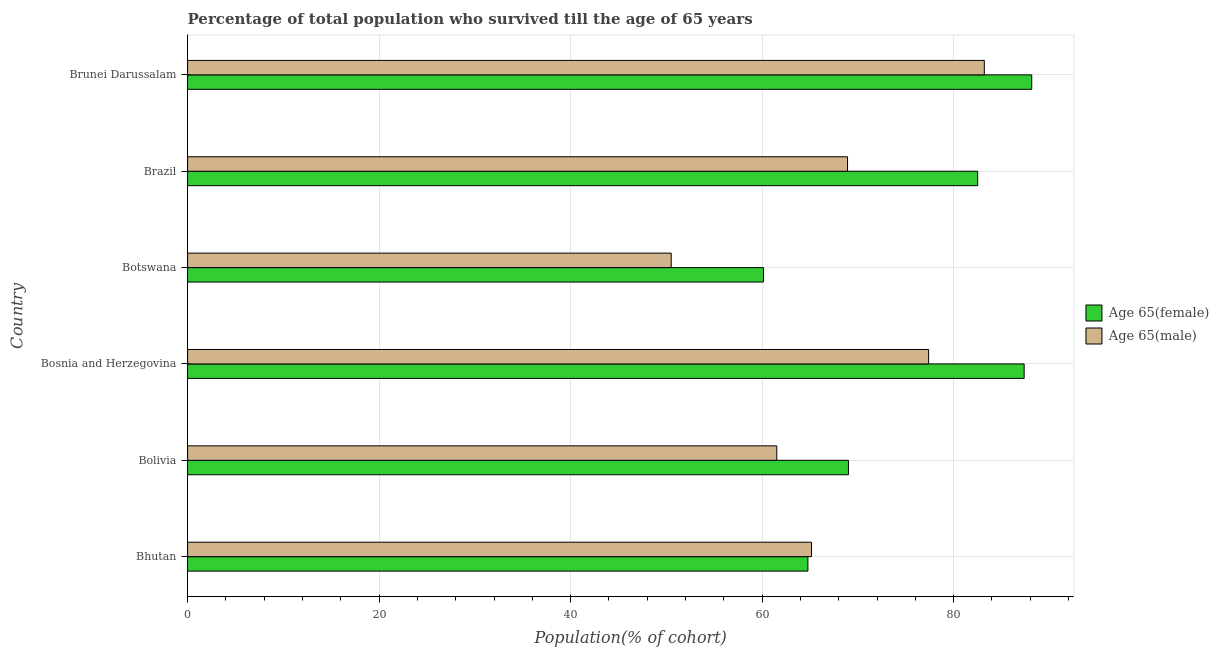How many different coloured bars are there?
Make the answer very short. 2. How many groups of bars are there?
Offer a terse response. 6. How many bars are there on the 5th tick from the bottom?
Make the answer very short. 2. What is the label of the 3rd group of bars from the top?
Make the answer very short. Botswana. In how many cases, is the number of bars for a given country not equal to the number of legend labels?
Ensure brevity in your answer.  0. What is the percentage of male population who survived till age of 65 in Brunei Darussalam?
Your response must be concise. 83.21. Across all countries, what is the maximum percentage of male population who survived till age of 65?
Offer a terse response. 83.21. Across all countries, what is the minimum percentage of female population who survived till age of 65?
Your response must be concise. 60.14. In which country was the percentage of male population who survived till age of 65 maximum?
Your response must be concise. Brunei Darussalam. In which country was the percentage of female population who survived till age of 65 minimum?
Make the answer very short. Botswana. What is the total percentage of male population who survived till age of 65 in the graph?
Make the answer very short. 406.72. What is the difference between the percentage of female population who survived till age of 65 in Botswana and that in Brunei Darussalam?
Your answer should be compact. -28.02. What is the difference between the percentage of female population who survived till age of 65 in Bolivia and the percentage of male population who survived till age of 65 in Brunei Darussalam?
Ensure brevity in your answer.  -14.19. What is the average percentage of male population who survived till age of 65 per country?
Ensure brevity in your answer.  67.79. What is the difference between the percentage of male population who survived till age of 65 and percentage of female population who survived till age of 65 in Bolivia?
Give a very brief answer. -7.49. What is the ratio of the percentage of female population who survived till age of 65 in Bolivia to that in Botswana?
Provide a succinct answer. 1.15. Is the percentage of male population who survived till age of 65 in Bolivia less than that in Brazil?
Make the answer very short. Yes. What is the difference between the highest and the second highest percentage of male population who survived till age of 65?
Offer a very short reply. 5.82. What is the difference between the highest and the lowest percentage of male population who survived till age of 65?
Offer a terse response. 32.7. In how many countries, is the percentage of male population who survived till age of 65 greater than the average percentage of male population who survived till age of 65 taken over all countries?
Your response must be concise. 3. Is the sum of the percentage of female population who survived till age of 65 in Bosnia and Herzegovina and Botswana greater than the maximum percentage of male population who survived till age of 65 across all countries?
Provide a succinct answer. Yes. What does the 2nd bar from the top in Bosnia and Herzegovina represents?
Provide a short and direct response. Age 65(female). What does the 1st bar from the bottom in Bosnia and Herzegovina represents?
Ensure brevity in your answer.  Age 65(female). How many bars are there?
Give a very brief answer. 12. Does the graph contain grids?
Ensure brevity in your answer.  Yes. Where does the legend appear in the graph?
Provide a short and direct response. Center right. What is the title of the graph?
Provide a short and direct response. Percentage of total population who survived till the age of 65 years. What is the label or title of the X-axis?
Provide a succinct answer. Population(% of cohort). What is the label or title of the Y-axis?
Ensure brevity in your answer.  Country. What is the Population(% of cohort) of Age 65(female) in Bhutan?
Your answer should be very brief. 64.78. What is the Population(% of cohort) in Age 65(male) in Bhutan?
Your answer should be compact. 65.16. What is the Population(% of cohort) of Age 65(female) in Bolivia?
Your answer should be very brief. 69.02. What is the Population(% of cohort) of Age 65(male) in Bolivia?
Provide a succinct answer. 61.53. What is the Population(% of cohort) in Age 65(female) in Bosnia and Herzegovina?
Provide a succinct answer. 87.37. What is the Population(% of cohort) in Age 65(male) in Bosnia and Herzegovina?
Offer a terse response. 77.39. What is the Population(% of cohort) in Age 65(female) in Botswana?
Offer a terse response. 60.14. What is the Population(% of cohort) of Age 65(male) in Botswana?
Your answer should be very brief. 50.51. What is the Population(% of cohort) in Age 65(female) in Brazil?
Give a very brief answer. 82.51. What is the Population(% of cohort) in Age 65(male) in Brazil?
Make the answer very short. 68.92. What is the Population(% of cohort) of Age 65(female) in Brunei Darussalam?
Your answer should be compact. 88.16. What is the Population(% of cohort) of Age 65(male) in Brunei Darussalam?
Your answer should be compact. 83.21. Across all countries, what is the maximum Population(% of cohort) of Age 65(female)?
Make the answer very short. 88.16. Across all countries, what is the maximum Population(% of cohort) of Age 65(male)?
Your answer should be very brief. 83.21. Across all countries, what is the minimum Population(% of cohort) of Age 65(female)?
Your answer should be compact. 60.14. Across all countries, what is the minimum Population(% of cohort) of Age 65(male)?
Your response must be concise. 50.51. What is the total Population(% of cohort) of Age 65(female) in the graph?
Offer a terse response. 451.99. What is the total Population(% of cohort) in Age 65(male) in the graph?
Provide a succinct answer. 406.72. What is the difference between the Population(% of cohort) in Age 65(female) in Bhutan and that in Bolivia?
Your answer should be very brief. -4.23. What is the difference between the Population(% of cohort) of Age 65(male) in Bhutan and that in Bolivia?
Give a very brief answer. 3.63. What is the difference between the Population(% of cohort) of Age 65(female) in Bhutan and that in Bosnia and Herzegovina?
Your answer should be very brief. -22.58. What is the difference between the Population(% of cohort) of Age 65(male) in Bhutan and that in Bosnia and Herzegovina?
Your response must be concise. -12.23. What is the difference between the Population(% of cohort) in Age 65(female) in Bhutan and that in Botswana?
Offer a very short reply. 4.64. What is the difference between the Population(% of cohort) in Age 65(male) in Bhutan and that in Botswana?
Give a very brief answer. 14.65. What is the difference between the Population(% of cohort) in Age 65(female) in Bhutan and that in Brazil?
Provide a short and direct response. -17.73. What is the difference between the Population(% of cohort) in Age 65(male) in Bhutan and that in Brazil?
Offer a terse response. -3.76. What is the difference between the Population(% of cohort) of Age 65(female) in Bhutan and that in Brunei Darussalam?
Provide a short and direct response. -23.38. What is the difference between the Population(% of cohort) in Age 65(male) in Bhutan and that in Brunei Darussalam?
Your response must be concise. -18.05. What is the difference between the Population(% of cohort) in Age 65(female) in Bolivia and that in Bosnia and Herzegovina?
Offer a terse response. -18.35. What is the difference between the Population(% of cohort) in Age 65(male) in Bolivia and that in Bosnia and Herzegovina?
Your answer should be very brief. -15.86. What is the difference between the Population(% of cohort) in Age 65(female) in Bolivia and that in Botswana?
Your response must be concise. 8.88. What is the difference between the Population(% of cohort) in Age 65(male) in Bolivia and that in Botswana?
Provide a short and direct response. 11.03. What is the difference between the Population(% of cohort) in Age 65(female) in Bolivia and that in Brazil?
Make the answer very short. -13.5. What is the difference between the Population(% of cohort) of Age 65(male) in Bolivia and that in Brazil?
Keep it short and to the point. -7.39. What is the difference between the Population(% of cohort) of Age 65(female) in Bolivia and that in Brunei Darussalam?
Your response must be concise. -19.14. What is the difference between the Population(% of cohort) of Age 65(male) in Bolivia and that in Brunei Darussalam?
Provide a short and direct response. -21.68. What is the difference between the Population(% of cohort) of Age 65(female) in Bosnia and Herzegovina and that in Botswana?
Make the answer very short. 27.23. What is the difference between the Population(% of cohort) in Age 65(male) in Bosnia and Herzegovina and that in Botswana?
Your response must be concise. 26.88. What is the difference between the Population(% of cohort) of Age 65(female) in Bosnia and Herzegovina and that in Brazil?
Provide a short and direct response. 4.85. What is the difference between the Population(% of cohort) in Age 65(male) in Bosnia and Herzegovina and that in Brazil?
Ensure brevity in your answer.  8.47. What is the difference between the Population(% of cohort) of Age 65(female) in Bosnia and Herzegovina and that in Brunei Darussalam?
Give a very brief answer. -0.79. What is the difference between the Population(% of cohort) in Age 65(male) in Bosnia and Herzegovina and that in Brunei Darussalam?
Provide a short and direct response. -5.82. What is the difference between the Population(% of cohort) of Age 65(female) in Botswana and that in Brazil?
Provide a short and direct response. -22.37. What is the difference between the Population(% of cohort) in Age 65(male) in Botswana and that in Brazil?
Offer a terse response. -18.42. What is the difference between the Population(% of cohort) of Age 65(female) in Botswana and that in Brunei Darussalam?
Keep it short and to the point. -28.02. What is the difference between the Population(% of cohort) of Age 65(male) in Botswana and that in Brunei Darussalam?
Keep it short and to the point. -32.7. What is the difference between the Population(% of cohort) of Age 65(female) in Brazil and that in Brunei Darussalam?
Offer a terse response. -5.65. What is the difference between the Population(% of cohort) in Age 65(male) in Brazil and that in Brunei Darussalam?
Make the answer very short. -14.28. What is the difference between the Population(% of cohort) of Age 65(female) in Bhutan and the Population(% of cohort) of Age 65(male) in Bolivia?
Your answer should be very brief. 3.25. What is the difference between the Population(% of cohort) in Age 65(female) in Bhutan and the Population(% of cohort) in Age 65(male) in Bosnia and Herzegovina?
Offer a very short reply. -12.61. What is the difference between the Population(% of cohort) of Age 65(female) in Bhutan and the Population(% of cohort) of Age 65(male) in Botswana?
Ensure brevity in your answer.  14.28. What is the difference between the Population(% of cohort) of Age 65(female) in Bhutan and the Population(% of cohort) of Age 65(male) in Brazil?
Make the answer very short. -4.14. What is the difference between the Population(% of cohort) in Age 65(female) in Bhutan and the Population(% of cohort) in Age 65(male) in Brunei Darussalam?
Your answer should be very brief. -18.42. What is the difference between the Population(% of cohort) of Age 65(female) in Bolivia and the Population(% of cohort) of Age 65(male) in Bosnia and Herzegovina?
Make the answer very short. -8.37. What is the difference between the Population(% of cohort) in Age 65(female) in Bolivia and the Population(% of cohort) in Age 65(male) in Botswana?
Your response must be concise. 18.51. What is the difference between the Population(% of cohort) of Age 65(female) in Bolivia and the Population(% of cohort) of Age 65(male) in Brazil?
Your response must be concise. 0.1. What is the difference between the Population(% of cohort) of Age 65(female) in Bolivia and the Population(% of cohort) of Age 65(male) in Brunei Darussalam?
Offer a terse response. -14.19. What is the difference between the Population(% of cohort) of Age 65(female) in Bosnia and Herzegovina and the Population(% of cohort) of Age 65(male) in Botswana?
Ensure brevity in your answer.  36.86. What is the difference between the Population(% of cohort) of Age 65(female) in Bosnia and Herzegovina and the Population(% of cohort) of Age 65(male) in Brazil?
Offer a terse response. 18.45. What is the difference between the Population(% of cohort) in Age 65(female) in Bosnia and Herzegovina and the Population(% of cohort) in Age 65(male) in Brunei Darussalam?
Your response must be concise. 4.16. What is the difference between the Population(% of cohort) of Age 65(female) in Botswana and the Population(% of cohort) of Age 65(male) in Brazil?
Offer a very short reply. -8.78. What is the difference between the Population(% of cohort) of Age 65(female) in Botswana and the Population(% of cohort) of Age 65(male) in Brunei Darussalam?
Your answer should be very brief. -23.07. What is the difference between the Population(% of cohort) in Age 65(female) in Brazil and the Population(% of cohort) in Age 65(male) in Brunei Darussalam?
Give a very brief answer. -0.69. What is the average Population(% of cohort) in Age 65(female) per country?
Your answer should be compact. 75.33. What is the average Population(% of cohort) of Age 65(male) per country?
Your response must be concise. 67.79. What is the difference between the Population(% of cohort) of Age 65(female) and Population(% of cohort) of Age 65(male) in Bhutan?
Make the answer very short. -0.37. What is the difference between the Population(% of cohort) of Age 65(female) and Population(% of cohort) of Age 65(male) in Bolivia?
Your response must be concise. 7.49. What is the difference between the Population(% of cohort) of Age 65(female) and Population(% of cohort) of Age 65(male) in Bosnia and Herzegovina?
Keep it short and to the point. 9.98. What is the difference between the Population(% of cohort) of Age 65(female) and Population(% of cohort) of Age 65(male) in Botswana?
Provide a short and direct response. 9.63. What is the difference between the Population(% of cohort) in Age 65(female) and Population(% of cohort) in Age 65(male) in Brazil?
Provide a succinct answer. 13.59. What is the difference between the Population(% of cohort) in Age 65(female) and Population(% of cohort) in Age 65(male) in Brunei Darussalam?
Offer a terse response. 4.95. What is the ratio of the Population(% of cohort) of Age 65(female) in Bhutan to that in Bolivia?
Make the answer very short. 0.94. What is the ratio of the Population(% of cohort) of Age 65(male) in Bhutan to that in Bolivia?
Your answer should be very brief. 1.06. What is the ratio of the Population(% of cohort) in Age 65(female) in Bhutan to that in Bosnia and Herzegovina?
Your response must be concise. 0.74. What is the ratio of the Population(% of cohort) in Age 65(male) in Bhutan to that in Bosnia and Herzegovina?
Your answer should be compact. 0.84. What is the ratio of the Population(% of cohort) in Age 65(female) in Bhutan to that in Botswana?
Give a very brief answer. 1.08. What is the ratio of the Population(% of cohort) of Age 65(male) in Bhutan to that in Botswana?
Make the answer very short. 1.29. What is the ratio of the Population(% of cohort) of Age 65(female) in Bhutan to that in Brazil?
Make the answer very short. 0.79. What is the ratio of the Population(% of cohort) in Age 65(male) in Bhutan to that in Brazil?
Give a very brief answer. 0.95. What is the ratio of the Population(% of cohort) of Age 65(female) in Bhutan to that in Brunei Darussalam?
Your answer should be very brief. 0.73. What is the ratio of the Population(% of cohort) in Age 65(male) in Bhutan to that in Brunei Darussalam?
Your response must be concise. 0.78. What is the ratio of the Population(% of cohort) of Age 65(female) in Bolivia to that in Bosnia and Herzegovina?
Offer a very short reply. 0.79. What is the ratio of the Population(% of cohort) of Age 65(male) in Bolivia to that in Bosnia and Herzegovina?
Keep it short and to the point. 0.8. What is the ratio of the Population(% of cohort) of Age 65(female) in Bolivia to that in Botswana?
Keep it short and to the point. 1.15. What is the ratio of the Population(% of cohort) of Age 65(male) in Bolivia to that in Botswana?
Provide a succinct answer. 1.22. What is the ratio of the Population(% of cohort) of Age 65(female) in Bolivia to that in Brazil?
Ensure brevity in your answer.  0.84. What is the ratio of the Population(% of cohort) of Age 65(male) in Bolivia to that in Brazil?
Offer a very short reply. 0.89. What is the ratio of the Population(% of cohort) of Age 65(female) in Bolivia to that in Brunei Darussalam?
Make the answer very short. 0.78. What is the ratio of the Population(% of cohort) of Age 65(male) in Bolivia to that in Brunei Darussalam?
Make the answer very short. 0.74. What is the ratio of the Population(% of cohort) in Age 65(female) in Bosnia and Herzegovina to that in Botswana?
Give a very brief answer. 1.45. What is the ratio of the Population(% of cohort) in Age 65(male) in Bosnia and Herzegovina to that in Botswana?
Your response must be concise. 1.53. What is the ratio of the Population(% of cohort) of Age 65(female) in Bosnia and Herzegovina to that in Brazil?
Offer a terse response. 1.06. What is the ratio of the Population(% of cohort) in Age 65(male) in Bosnia and Herzegovina to that in Brazil?
Ensure brevity in your answer.  1.12. What is the ratio of the Population(% of cohort) in Age 65(female) in Bosnia and Herzegovina to that in Brunei Darussalam?
Give a very brief answer. 0.99. What is the ratio of the Population(% of cohort) of Age 65(male) in Bosnia and Herzegovina to that in Brunei Darussalam?
Offer a very short reply. 0.93. What is the ratio of the Population(% of cohort) of Age 65(female) in Botswana to that in Brazil?
Give a very brief answer. 0.73. What is the ratio of the Population(% of cohort) of Age 65(male) in Botswana to that in Brazil?
Ensure brevity in your answer.  0.73. What is the ratio of the Population(% of cohort) of Age 65(female) in Botswana to that in Brunei Darussalam?
Your response must be concise. 0.68. What is the ratio of the Population(% of cohort) of Age 65(male) in Botswana to that in Brunei Darussalam?
Offer a very short reply. 0.61. What is the ratio of the Population(% of cohort) of Age 65(female) in Brazil to that in Brunei Darussalam?
Your response must be concise. 0.94. What is the ratio of the Population(% of cohort) of Age 65(male) in Brazil to that in Brunei Darussalam?
Your answer should be compact. 0.83. What is the difference between the highest and the second highest Population(% of cohort) of Age 65(female)?
Keep it short and to the point. 0.79. What is the difference between the highest and the second highest Population(% of cohort) of Age 65(male)?
Provide a succinct answer. 5.82. What is the difference between the highest and the lowest Population(% of cohort) in Age 65(female)?
Provide a succinct answer. 28.02. What is the difference between the highest and the lowest Population(% of cohort) in Age 65(male)?
Your response must be concise. 32.7. 